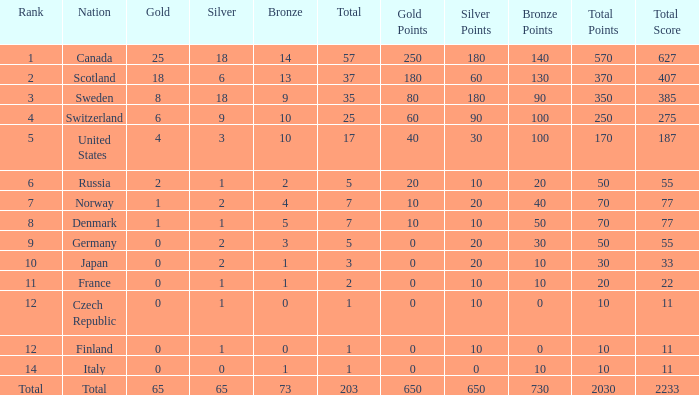What is the lowest total when the rank is 14 and the gold medals is larger than 0? None. 